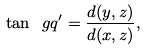<formula> <loc_0><loc_0><loc_500><loc_500>\tan \ g q ^ { \prime } = \frac { d ( y , z ) } { d ( x , z ) } ,</formula> 